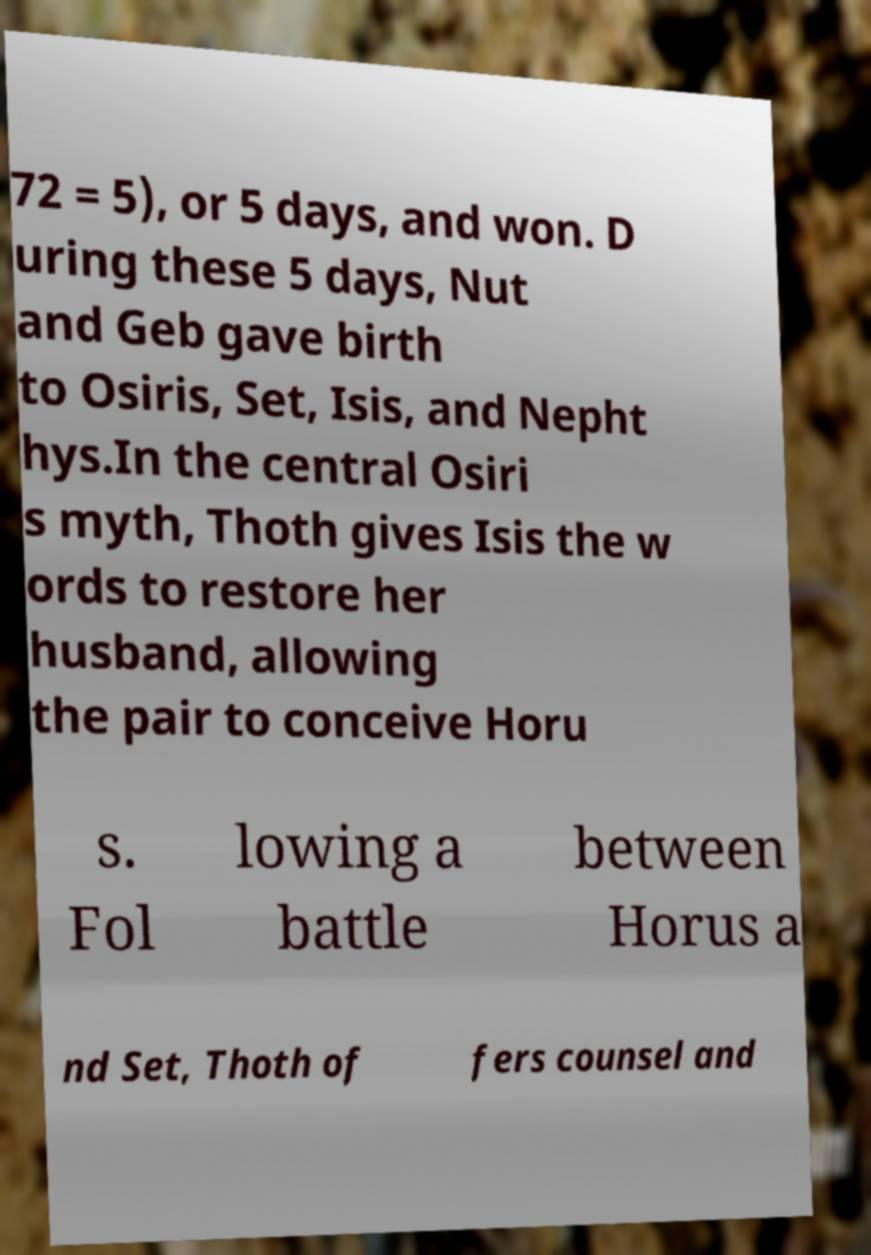Could you extract and type out the text from this image? 72 = 5), or 5 days, and won. D uring these 5 days, Nut and Geb gave birth to Osiris, Set, Isis, and Nepht hys.In the central Osiri s myth, Thoth gives Isis the w ords to restore her husband, allowing the pair to conceive Horu s. Fol lowing a battle between Horus a nd Set, Thoth of fers counsel and 